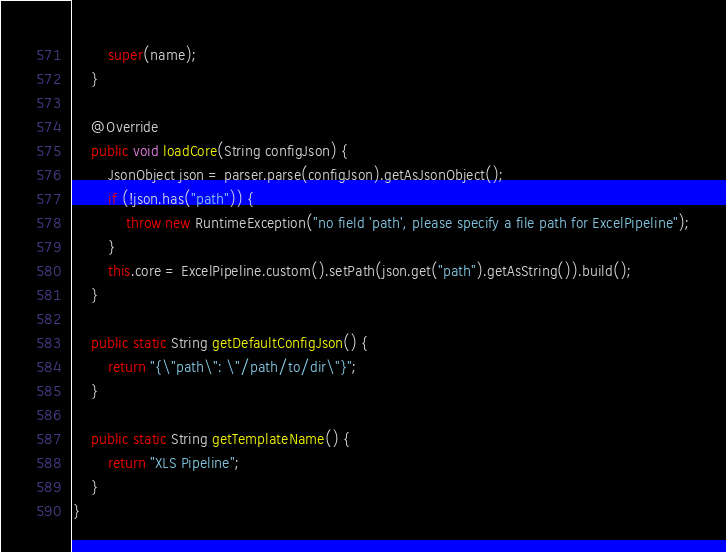Convert code to text. <code><loc_0><loc_0><loc_500><loc_500><_Java_>        super(name);
    }

    @Override
    public void loadCore(String configJson) {
        JsonObject json = parser.parse(configJson).getAsJsonObject();
        if (!json.has("path")) {
            throw new RuntimeException("no field 'path', please specify a file path for ExcelPipeline");
        }
        this.core = ExcelPipeline.custom().setPath(json.get("path").getAsString()).build();
    }

    public static String getDefaultConfigJson() {
        return "{\"path\": \"/path/to/dir\"}";
    }

    public static String getTemplateName() {
        return "XLS Pipeline";
    }
}
</code> 